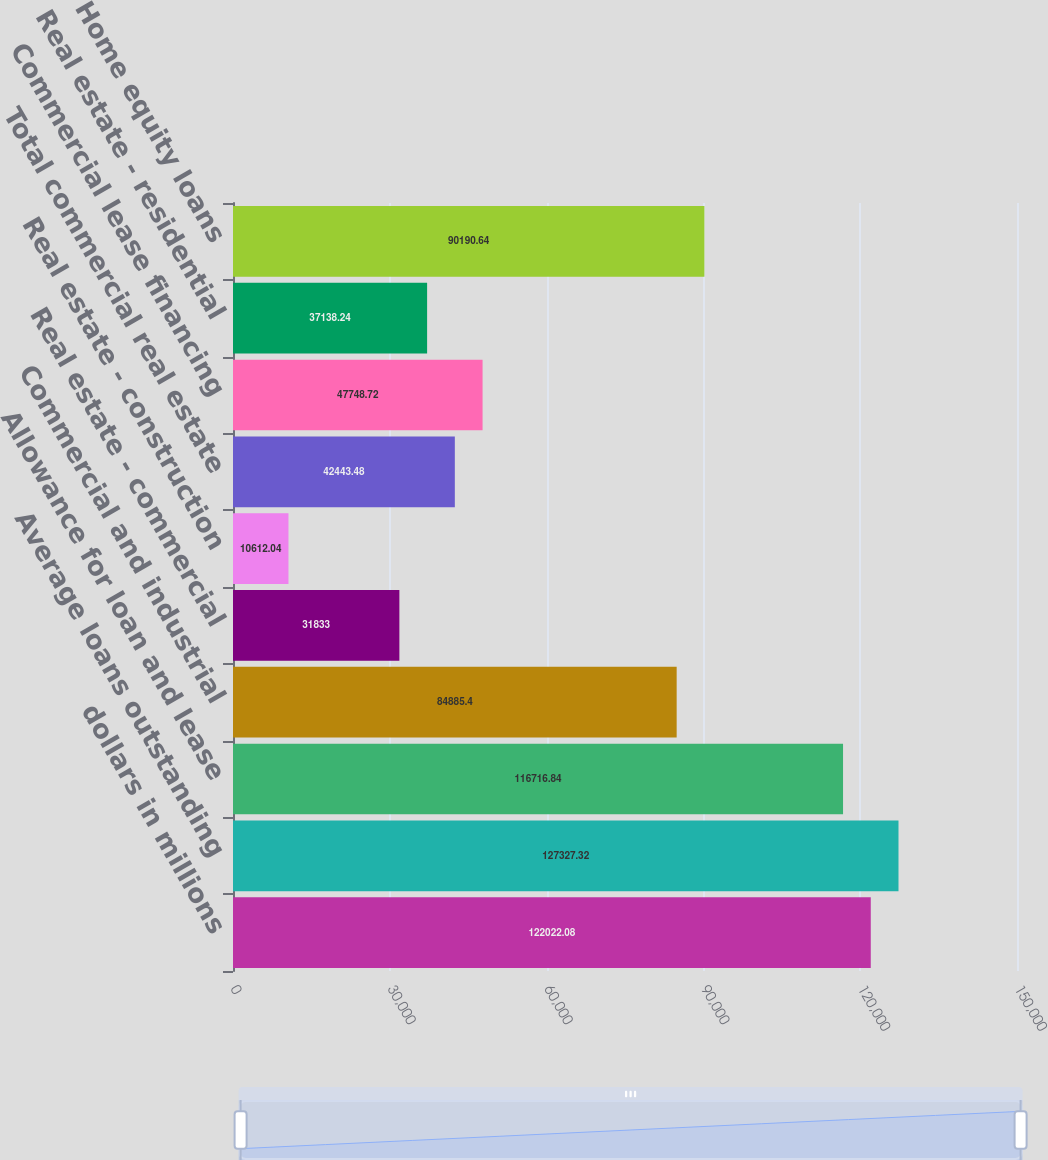<chart> <loc_0><loc_0><loc_500><loc_500><bar_chart><fcel>dollars in millions<fcel>Average loans outstanding<fcel>Allowance for loan and lease<fcel>Commercial and industrial<fcel>Real estate - commercial<fcel>Real estate - construction<fcel>Total commercial real estate<fcel>Commercial lease financing<fcel>Real estate - residential<fcel>Home equity loans<nl><fcel>122022<fcel>127327<fcel>116717<fcel>84885.4<fcel>31833<fcel>10612<fcel>42443.5<fcel>47748.7<fcel>37138.2<fcel>90190.6<nl></chart> 